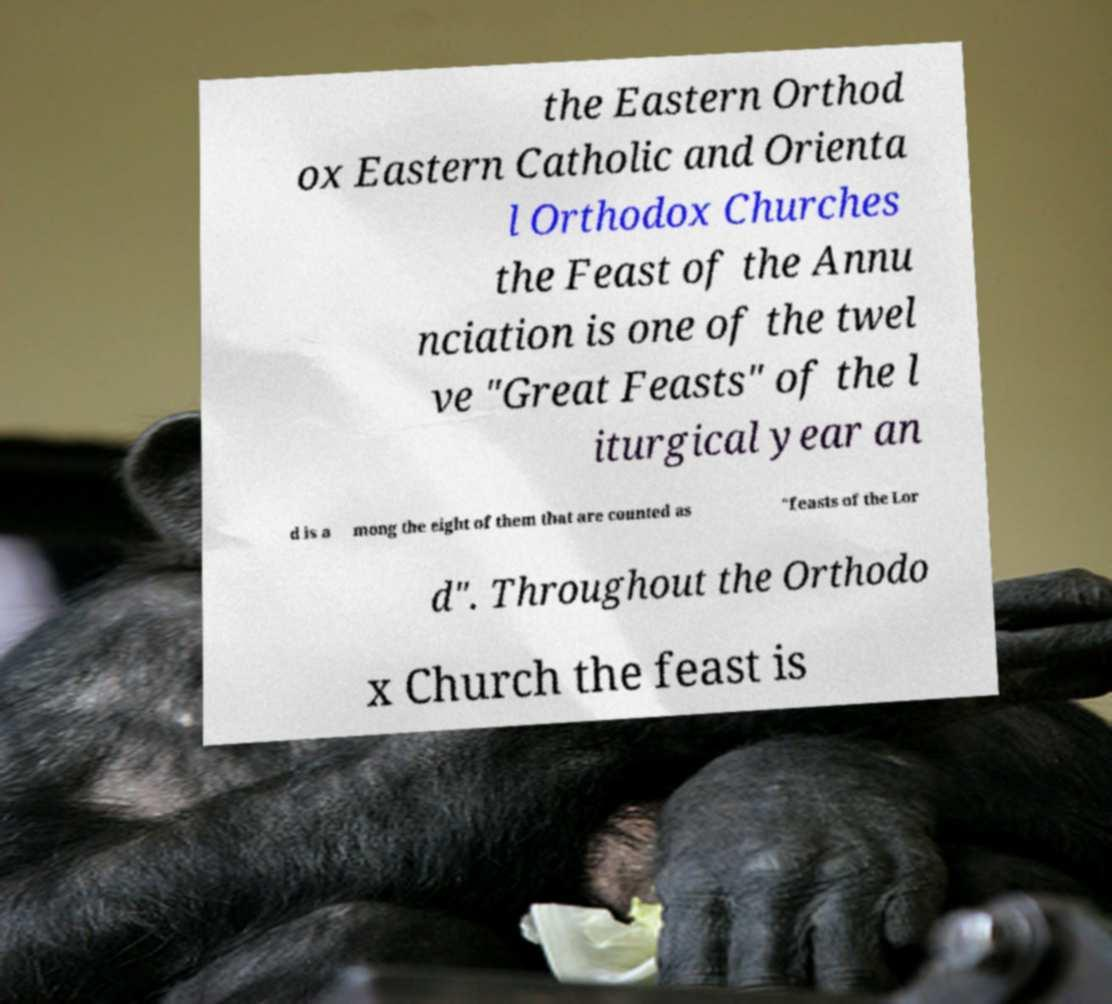Please read and relay the text visible in this image. What does it say? the Eastern Orthod ox Eastern Catholic and Orienta l Orthodox Churches the Feast of the Annu nciation is one of the twel ve "Great Feasts" of the l iturgical year an d is a mong the eight of them that are counted as "feasts of the Lor d". Throughout the Orthodo x Church the feast is 